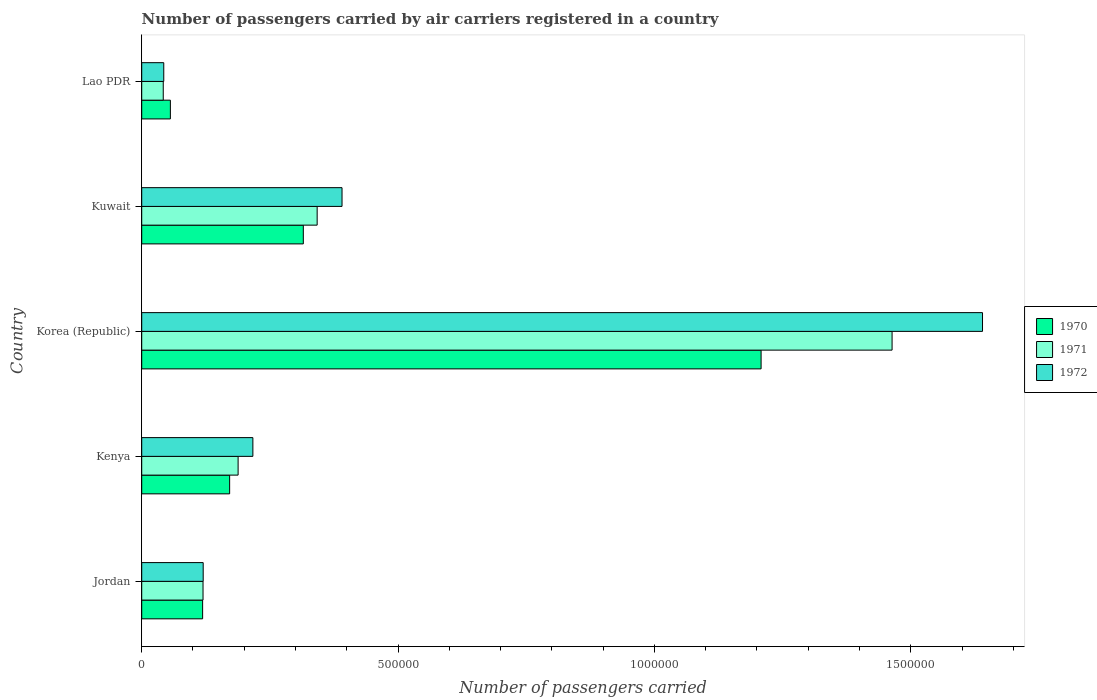How many groups of bars are there?
Make the answer very short. 5. Are the number of bars per tick equal to the number of legend labels?
Provide a short and direct response. Yes. Are the number of bars on each tick of the Y-axis equal?
Offer a terse response. Yes. What is the label of the 5th group of bars from the top?
Your answer should be compact. Jordan. What is the number of passengers carried by air carriers in 1970 in Jordan?
Make the answer very short. 1.19e+05. Across all countries, what is the maximum number of passengers carried by air carriers in 1970?
Make the answer very short. 1.21e+06. Across all countries, what is the minimum number of passengers carried by air carriers in 1971?
Make the answer very short. 4.20e+04. In which country was the number of passengers carried by air carriers in 1971 minimum?
Offer a very short reply. Lao PDR. What is the total number of passengers carried by air carriers in 1970 in the graph?
Provide a short and direct response. 1.87e+06. What is the difference between the number of passengers carried by air carriers in 1972 in Korea (Republic) and that in Lao PDR?
Offer a terse response. 1.60e+06. What is the difference between the number of passengers carried by air carriers in 1972 in Lao PDR and the number of passengers carried by air carriers in 1970 in Kenya?
Offer a very short reply. -1.28e+05. What is the average number of passengers carried by air carriers in 1972 per country?
Your answer should be very brief. 4.82e+05. What is the difference between the number of passengers carried by air carriers in 1972 and number of passengers carried by air carriers in 1971 in Kenya?
Your answer should be compact. 2.88e+04. In how many countries, is the number of passengers carried by air carriers in 1972 greater than 700000 ?
Offer a terse response. 1. What is the ratio of the number of passengers carried by air carriers in 1970 in Jordan to that in Lao PDR?
Make the answer very short. 2.13. What is the difference between the highest and the second highest number of passengers carried by air carriers in 1970?
Ensure brevity in your answer.  8.93e+05. What is the difference between the highest and the lowest number of passengers carried by air carriers in 1970?
Make the answer very short. 1.15e+06. Is the sum of the number of passengers carried by air carriers in 1972 in Kenya and Kuwait greater than the maximum number of passengers carried by air carriers in 1971 across all countries?
Ensure brevity in your answer.  No. What does the 2nd bar from the top in Jordan represents?
Your response must be concise. 1971. Is it the case that in every country, the sum of the number of passengers carried by air carriers in 1972 and number of passengers carried by air carriers in 1970 is greater than the number of passengers carried by air carriers in 1971?
Offer a very short reply. Yes. How many bars are there?
Keep it short and to the point. 15. Are all the bars in the graph horizontal?
Provide a short and direct response. Yes. What is the difference between two consecutive major ticks on the X-axis?
Offer a very short reply. 5.00e+05. Where does the legend appear in the graph?
Provide a succinct answer. Center right. How many legend labels are there?
Your answer should be compact. 3. What is the title of the graph?
Your response must be concise. Number of passengers carried by air carriers registered in a country. Does "1964" appear as one of the legend labels in the graph?
Ensure brevity in your answer.  No. What is the label or title of the X-axis?
Provide a succinct answer. Number of passengers carried. What is the label or title of the Y-axis?
Keep it short and to the point. Country. What is the Number of passengers carried of 1970 in Jordan?
Keep it short and to the point. 1.19e+05. What is the Number of passengers carried of 1971 in Jordan?
Your answer should be compact. 1.20e+05. What is the Number of passengers carried of 1972 in Jordan?
Offer a very short reply. 1.20e+05. What is the Number of passengers carried of 1970 in Kenya?
Provide a short and direct response. 1.72e+05. What is the Number of passengers carried of 1971 in Kenya?
Your response must be concise. 1.88e+05. What is the Number of passengers carried in 1972 in Kenya?
Your answer should be compact. 2.17e+05. What is the Number of passengers carried of 1970 in Korea (Republic)?
Offer a very short reply. 1.21e+06. What is the Number of passengers carried in 1971 in Korea (Republic)?
Offer a terse response. 1.46e+06. What is the Number of passengers carried of 1972 in Korea (Republic)?
Keep it short and to the point. 1.64e+06. What is the Number of passengers carried of 1970 in Kuwait?
Ensure brevity in your answer.  3.15e+05. What is the Number of passengers carried of 1971 in Kuwait?
Keep it short and to the point. 3.42e+05. What is the Number of passengers carried in 1972 in Kuwait?
Your answer should be very brief. 3.91e+05. What is the Number of passengers carried in 1970 in Lao PDR?
Your answer should be very brief. 5.59e+04. What is the Number of passengers carried in 1971 in Lao PDR?
Offer a very short reply. 4.20e+04. What is the Number of passengers carried in 1972 in Lao PDR?
Your answer should be very brief. 4.30e+04. Across all countries, what is the maximum Number of passengers carried of 1970?
Ensure brevity in your answer.  1.21e+06. Across all countries, what is the maximum Number of passengers carried of 1971?
Your answer should be compact. 1.46e+06. Across all countries, what is the maximum Number of passengers carried of 1972?
Make the answer very short. 1.64e+06. Across all countries, what is the minimum Number of passengers carried in 1970?
Your answer should be compact. 5.59e+04. Across all countries, what is the minimum Number of passengers carried in 1971?
Give a very brief answer. 4.20e+04. Across all countries, what is the minimum Number of passengers carried of 1972?
Your answer should be very brief. 4.30e+04. What is the total Number of passengers carried in 1970 in the graph?
Make the answer very short. 1.87e+06. What is the total Number of passengers carried of 1971 in the graph?
Provide a succinct answer. 2.16e+06. What is the total Number of passengers carried of 1972 in the graph?
Keep it short and to the point. 2.41e+06. What is the difference between the Number of passengers carried in 1970 in Jordan and that in Kenya?
Offer a very short reply. -5.27e+04. What is the difference between the Number of passengers carried of 1971 in Jordan and that in Kenya?
Keep it short and to the point. -6.84e+04. What is the difference between the Number of passengers carried in 1972 in Jordan and that in Kenya?
Your answer should be very brief. -9.69e+04. What is the difference between the Number of passengers carried of 1970 in Jordan and that in Korea (Republic)?
Your answer should be very brief. -1.09e+06. What is the difference between the Number of passengers carried in 1971 in Jordan and that in Korea (Republic)?
Offer a very short reply. -1.34e+06. What is the difference between the Number of passengers carried of 1972 in Jordan and that in Korea (Republic)?
Provide a succinct answer. -1.52e+06. What is the difference between the Number of passengers carried of 1970 in Jordan and that in Kuwait?
Make the answer very short. -1.96e+05. What is the difference between the Number of passengers carried in 1971 in Jordan and that in Kuwait?
Offer a very short reply. -2.23e+05. What is the difference between the Number of passengers carried in 1972 in Jordan and that in Kuwait?
Ensure brevity in your answer.  -2.71e+05. What is the difference between the Number of passengers carried in 1970 in Jordan and that in Lao PDR?
Provide a succinct answer. 6.29e+04. What is the difference between the Number of passengers carried in 1971 in Jordan and that in Lao PDR?
Offer a terse response. 7.76e+04. What is the difference between the Number of passengers carried in 1972 in Jordan and that in Lao PDR?
Provide a succinct answer. 7.69e+04. What is the difference between the Number of passengers carried of 1970 in Kenya and that in Korea (Republic)?
Offer a terse response. -1.04e+06. What is the difference between the Number of passengers carried in 1971 in Kenya and that in Korea (Republic)?
Give a very brief answer. -1.28e+06. What is the difference between the Number of passengers carried of 1972 in Kenya and that in Korea (Republic)?
Your answer should be very brief. -1.42e+06. What is the difference between the Number of passengers carried in 1970 in Kenya and that in Kuwait?
Your answer should be very brief. -1.44e+05. What is the difference between the Number of passengers carried of 1971 in Kenya and that in Kuwait?
Your answer should be compact. -1.54e+05. What is the difference between the Number of passengers carried in 1972 in Kenya and that in Kuwait?
Offer a very short reply. -1.74e+05. What is the difference between the Number of passengers carried of 1970 in Kenya and that in Lao PDR?
Provide a short and direct response. 1.16e+05. What is the difference between the Number of passengers carried of 1971 in Kenya and that in Lao PDR?
Offer a terse response. 1.46e+05. What is the difference between the Number of passengers carried of 1972 in Kenya and that in Lao PDR?
Your answer should be compact. 1.74e+05. What is the difference between the Number of passengers carried in 1970 in Korea (Republic) and that in Kuwait?
Ensure brevity in your answer.  8.93e+05. What is the difference between the Number of passengers carried in 1971 in Korea (Republic) and that in Kuwait?
Your answer should be very brief. 1.12e+06. What is the difference between the Number of passengers carried in 1972 in Korea (Republic) and that in Kuwait?
Offer a terse response. 1.25e+06. What is the difference between the Number of passengers carried in 1970 in Korea (Republic) and that in Lao PDR?
Provide a succinct answer. 1.15e+06. What is the difference between the Number of passengers carried of 1971 in Korea (Republic) and that in Lao PDR?
Ensure brevity in your answer.  1.42e+06. What is the difference between the Number of passengers carried in 1972 in Korea (Republic) and that in Lao PDR?
Make the answer very short. 1.60e+06. What is the difference between the Number of passengers carried in 1970 in Kuwait and that in Lao PDR?
Your answer should be compact. 2.59e+05. What is the difference between the Number of passengers carried of 1971 in Kuwait and that in Lao PDR?
Your answer should be compact. 3.00e+05. What is the difference between the Number of passengers carried in 1972 in Kuwait and that in Lao PDR?
Your response must be concise. 3.48e+05. What is the difference between the Number of passengers carried in 1970 in Jordan and the Number of passengers carried in 1971 in Kenya?
Offer a terse response. -6.92e+04. What is the difference between the Number of passengers carried of 1970 in Jordan and the Number of passengers carried of 1972 in Kenya?
Keep it short and to the point. -9.80e+04. What is the difference between the Number of passengers carried in 1971 in Jordan and the Number of passengers carried in 1972 in Kenya?
Your answer should be very brief. -9.72e+04. What is the difference between the Number of passengers carried in 1970 in Jordan and the Number of passengers carried in 1971 in Korea (Republic)?
Keep it short and to the point. -1.34e+06. What is the difference between the Number of passengers carried in 1970 in Jordan and the Number of passengers carried in 1972 in Korea (Republic)?
Keep it short and to the point. -1.52e+06. What is the difference between the Number of passengers carried in 1971 in Jordan and the Number of passengers carried in 1972 in Korea (Republic)?
Your answer should be very brief. -1.52e+06. What is the difference between the Number of passengers carried in 1970 in Jordan and the Number of passengers carried in 1971 in Kuwait?
Your response must be concise. -2.23e+05. What is the difference between the Number of passengers carried in 1970 in Jordan and the Number of passengers carried in 1972 in Kuwait?
Your response must be concise. -2.72e+05. What is the difference between the Number of passengers carried in 1971 in Jordan and the Number of passengers carried in 1972 in Kuwait?
Your response must be concise. -2.71e+05. What is the difference between the Number of passengers carried in 1970 in Jordan and the Number of passengers carried in 1971 in Lao PDR?
Offer a terse response. 7.68e+04. What is the difference between the Number of passengers carried of 1970 in Jordan and the Number of passengers carried of 1972 in Lao PDR?
Keep it short and to the point. 7.58e+04. What is the difference between the Number of passengers carried in 1971 in Jordan and the Number of passengers carried in 1972 in Lao PDR?
Offer a terse response. 7.66e+04. What is the difference between the Number of passengers carried in 1970 in Kenya and the Number of passengers carried in 1971 in Korea (Republic)?
Make the answer very short. -1.29e+06. What is the difference between the Number of passengers carried in 1970 in Kenya and the Number of passengers carried in 1972 in Korea (Republic)?
Your answer should be compact. -1.47e+06. What is the difference between the Number of passengers carried in 1971 in Kenya and the Number of passengers carried in 1972 in Korea (Republic)?
Provide a succinct answer. -1.45e+06. What is the difference between the Number of passengers carried in 1970 in Kenya and the Number of passengers carried in 1971 in Kuwait?
Provide a succinct answer. -1.71e+05. What is the difference between the Number of passengers carried in 1970 in Kenya and the Number of passengers carried in 1972 in Kuwait?
Offer a very short reply. -2.19e+05. What is the difference between the Number of passengers carried of 1971 in Kenya and the Number of passengers carried of 1972 in Kuwait?
Your answer should be compact. -2.03e+05. What is the difference between the Number of passengers carried of 1970 in Kenya and the Number of passengers carried of 1971 in Lao PDR?
Provide a short and direct response. 1.30e+05. What is the difference between the Number of passengers carried in 1970 in Kenya and the Number of passengers carried in 1972 in Lao PDR?
Your answer should be very brief. 1.28e+05. What is the difference between the Number of passengers carried in 1971 in Kenya and the Number of passengers carried in 1972 in Lao PDR?
Ensure brevity in your answer.  1.45e+05. What is the difference between the Number of passengers carried in 1970 in Korea (Republic) and the Number of passengers carried in 1971 in Kuwait?
Offer a terse response. 8.66e+05. What is the difference between the Number of passengers carried in 1970 in Korea (Republic) and the Number of passengers carried in 1972 in Kuwait?
Keep it short and to the point. 8.17e+05. What is the difference between the Number of passengers carried of 1971 in Korea (Republic) and the Number of passengers carried of 1972 in Kuwait?
Your answer should be very brief. 1.07e+06. What is the difference between the Number of passengers carried of 1970 in Korea (Republic) and the Number of passengers carried of 1971 in Lao PDR?
Provide a short and direct response. 1.17e+06. What is the difference between the Number of passengers carried in 1970 in Korea (Republic) and the Number of passengers carried in 1972 in Lao PDR?
Offer a very short reply. 1.17e+06. What is the difference between the Number of passengers carried of 1971 in Korea (Republic) and the Number of passengers carried of 1972 in Lao PDR?
Your answer should be compact. 1.42e+06. What is the difference between the Number of passengers carried of 1970 in Kuwait and the Number of passengers carried of 1971 in Lao PDR?
Make the answer very short. 2.73e+05. What is the difference between the Number of passengers carried of 1970 in Kuwait and the Number of passengers carried of 1972 in Lao PDR?
Your response must be concise. 2.72e+05. What is the difference between the Number of passengers carried in 1971 in Kuwait and the Number of passengers carried in 1972 in Lao PDR?
Offer a terse response. 2.99e+05. What is the average Number of passengers carried of 1970 per country?
Provide a succinct answer. 3.74e+05. What is the average Number of passengers carried in 1971 per country?
Give a very brief answer. 4.31e+05. What is the average Number of passengers carried in 1972 per country?
Your answer should be very brief. 4.82e+05. What is the difference between the Number of passengers carried in 1970 and Number of passengers carried in 1971 in Jordan?
Offer a terse response. -800. What is the difference between the Number of passengers carried of 1970 and Number of passengers carried of 1972 in Jordan?
Offer a very short reply. -1100. What is the difference between the Number of passengers carried of 1971 and Number of passengers carried of 1972 in Jordan?
Your answer should be compact. -300. What is the difference between the Number of passengers carried of 1970 and Number of passengers carried of 1971 in Kenya?
Ensure brevity in your answer.  -1.65e+04. What is the difference between the Number of passengers carried of 1970 and Number of passengers carried of 1972 in Kenya?
Provide a short and direct response. -4.53e+04. What is the difference between the Number of passengers carried in 1971 and Number of passengers carried in 1972 in Kenya?
Your response must be concise. -2.88e+04. What is the difference between the Number of passengers carried of 1970 and Number of passengers carried of 1971 in Korea (Republic)?
Your response must be concise. -2.56e+05. What is the difference between the Number of passengers carried in 1970 and Number of passengers carried in 1972 in Korea (Republic)?
Provide a succinct answer. -4.32e+05. What is the difference between the Number of passengers carried in 1971 and Number of passengers carried in 1972 in Korea (Republic)?
Provide a succinct answer. -1.76e+05. What is the difference between the Number of passengers carried of 1970 and Number of passengers carried of 1971 in Kuwait?
Keep it short and to the point. -2.70e+04. What is the difference between the Number of passengers carried of 1970 and Number of passengers carried of 1972 in Kuwait?
Provide a short and direct response. -7.55e+04. What is the difference between the Number of passengers carried in 1971 and Number of passengers carried in 1972 in Kuwait?
Your answer should be compact. -4.85e+04. What is the difference between the Number of passengers carried in 1970 and Number of passengers carried in 1971 in Lao PDR?
Your response must be concise. 1.39e+04. What is the difference between the Number of passengers carried of 1970 and Number of passengers carried of 1972 in Lao PDR?
Give a very brief answer. 1.29e+04. What is the difference between the Number of passengers carried of 1971 and Number of passengers carried of 1972 in Lao PDR?
Make the answer very short. -1000. What is the ratio of the Number of passengers carried in 1970 in Jordan to that in Kenya?
Your answer should be very brief. 0.69. What is the ratio of the Number of passengers carried of 1971 in Jordan to that in Kenya?
Provide a succinct answer. 0.64. What is the ratio of the Number of passengers carried of 1972 in Jordan to that in Kenya?
Provide a short and direct response. 0.55. What is the ratio of the Number of passengers carried of 1970 in Jordan to that in Korea (Republic)?
Keep it short and to the point. 0.1. What is the ratio of the Number of passengers carried of 1971 in Jordan to that in Korea (Republic)?
Provide a succinct answer. 0.08. What is the ratio of the Number of passengers carried in 1972 in Jordan to that in Korea (Republic)?
Offer a terse response. 0.07. What is the ratio of the Number of passengers carried of 1970 in Jordan to that in Kuwait?
Offer a terse response. 0.38. What is the ratio of the Number of passengers carried of 1971 in Jordan to that in Kuwait?
Give a very brief answer. 0.35. What is the ratio of the Number of passengers carried of 1972 in Jordan to that in Kuwait?
Provide a succinct answer. 0.31. What is the ratio of the Number of passengers carried in 1970 in Jordan to that in Lao PDR?
Give a very brief answer. 2.13. What is the ratio of the Number of passengers carried in 1971 in Jordan to that in Lao PDR?
Keep it short and to the point. 2.85. What is the ratio of the Number of passengers carried of 1972 in Jordan to that in Lao PDR?
Your response must be concise. 2.79. What is the ratio of the Number of passengers carried in 1970 in Kenya to that in Korea (Republic)?
Your response must be concise. 0.14. What is the ratio of the Number of passengers carried of 1971 in Kenya to that in Korea (Republic)?
Give a very brief answer. 0.13. What is the ratio of the Number of passengers carried of 1972 in Kenya to that in Korea (Republic)?
Your answer should be very brief. 0.13. What is the ratio of the Number of passengers carried of 1970 in Kenya to that in Kuwait?
Offer a terse response. 0.54. What is the ratio of the Number of passengers carried of 1971 in Kenya to that in Kuwait?
Provide a short and direct response. 0.55. What is the ratio of the Number of passengers carried in 1972 in Kenya to that in Kuwait?
Ensure brevity in your answer.  0.55. What is the ratio of the Number of passengers carried in 1970 in Kenya to that in Lao PDR?
Your answer should be compact. 3.07. What is the ratio of the Number of passengers carried in 1971 in Kenya to that in Lao PDR?
Your answer should be very brief. 4.48. What is the ratio of the Number of passengers carried of 1972 in Kenya to that in Lao PDR?
Provide a succinct answer. 5.04. What is the ratio of the Number of passengers carried of 1970 in Korea (Republic) to that in Kuwait?
Provide a succinct answer. 3.83. What is the ratio of the Number of passengers carried in 1971 in Korea (Republic) to that in Kuwait?
Provide a succinct answer. 4.28. What is the ratio of the Number of passengers carried of 1972 in Korea (Republic) to that in Kuwait?
Make the answer very short. 4.2. What is the ratio of the Number of passengers carried of 1970 in Korea (Republic) to that in Lao PDR?
Give a very brief answer. 21.61. What is the ratio of the Number of passengers carried in 1971 in Korea (Republic) to that in Lao PDR?
Keep it short and to the point. 34.85. What is the ratio of the Number of passengers carried of 1972 in Korea (Republic) to that in Lao PDR?
Make the answer very short. 38.14. What is the ratio of the Number of passengers carried in 1970 in Kuwait to that in Lao PDR?
Offer a very short reply. 5.64. What is the ratio of the Number of passengers carried of 1971 in Kuwait to that in Lao PDR?
Provide a short and direct response. 8.15. What is the ratio of the Number of passengers carried in 1972 in Kuwait to that in Lao PDR?
Offer a terse response. 9.09. What is the difference between the highest and the second highest Number of passengers carried in 1970?
Make the answer very short. 8.93e+05. What is the difference between the highest and the second highest Number of passengers carried of 1971?
Ensure brevity in your answer.  1.12e+06. What is the difference between the highest and the second highest Number of passengers carried of 1972?
Provide a short and direct response. 1.25e+06. What is the difference between the highest and the lowest Number of passengers carried in 1970?
Offer a very short reply. 1.15e+06. What is the difference between the highest and the lowest Number of passengers carried in 1971?
Provide a succinct answer. 1.42e+06. What is the difference between the highest and the lowest Number of passengers carried in 1972?
Provide a succinct answer. 1.60e+06. 